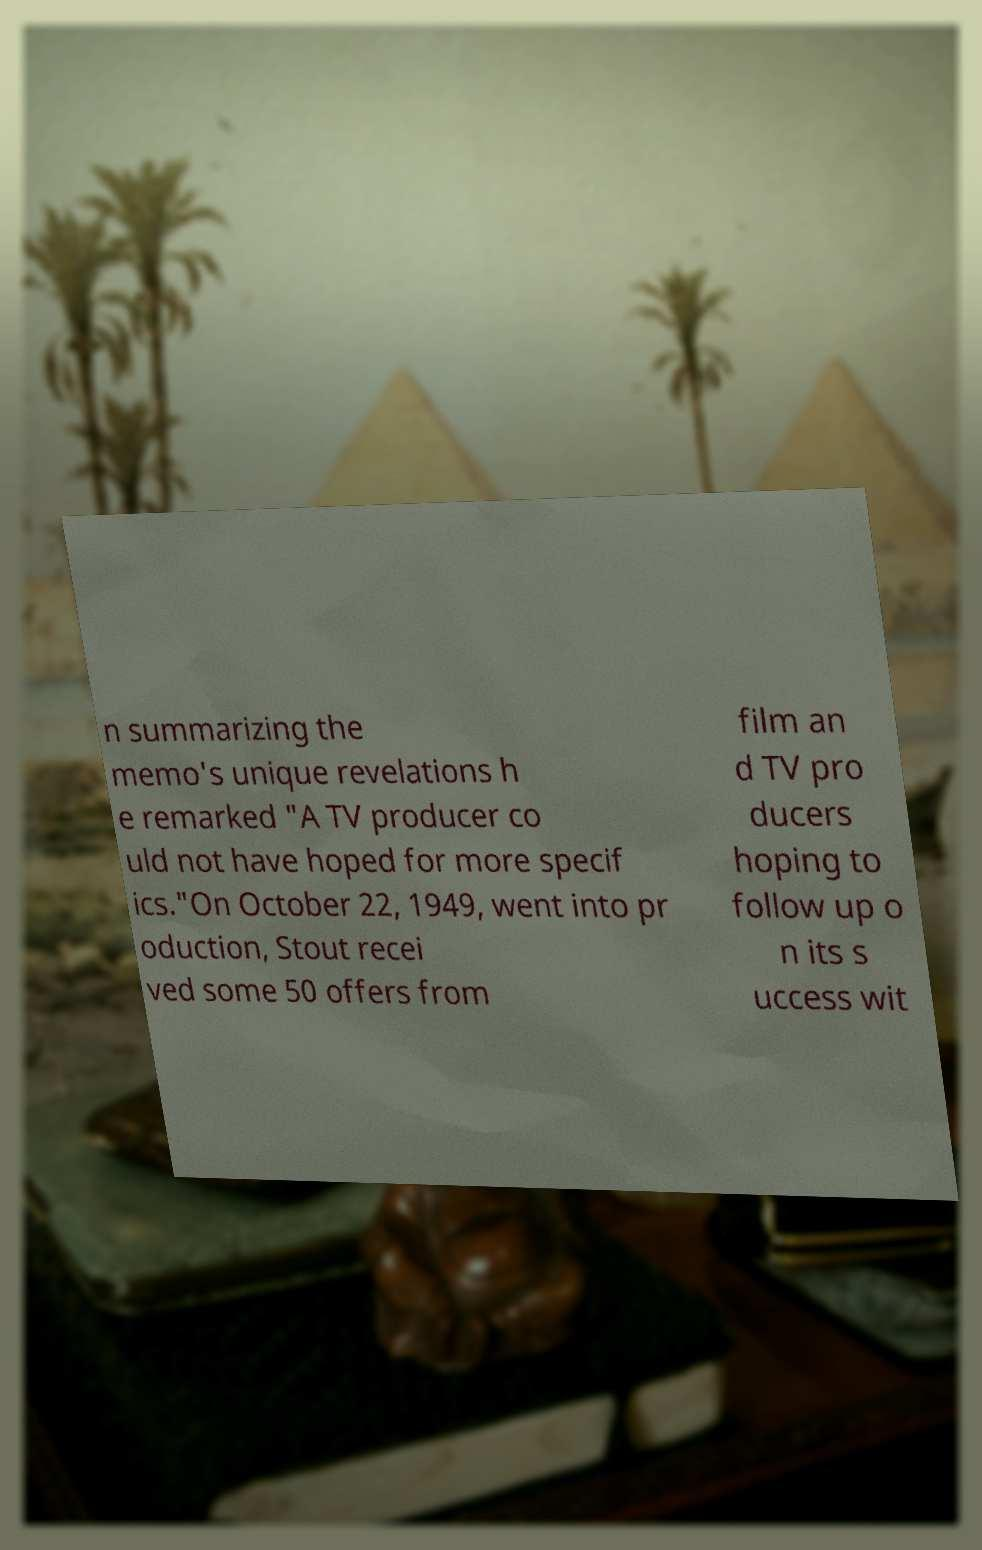Please identify and transcribe the text found in this image. n summarizing the memo's unique revelations h e remarked "A TV producer co uld not have hoped for more specif ics."On October 22, 1949, went into pr oduction, Stout recei ved some 50 offers from film an d TV pro ducers hoping to follow up o n its s uccess wit 